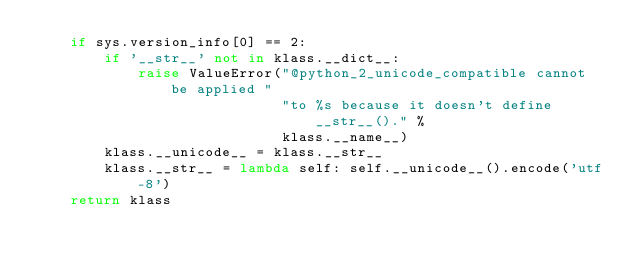<code> <loc_0><loc_0><loc_500><loc_500><_Python_>    if sys.version_info[0] == 2:
        if '__str__' not in klass.__dict__:
            raise ValueError("@python_2_unicode_compatible cannot be applied "
                             "to %s because it doesn't define __str__()." %
                             klass.__name__)
        klass.__unicode__ = klass.__str__
        klass.__str__ = lambda self: self.__unicode__().encode('utf-8')
    return klass
</code> 